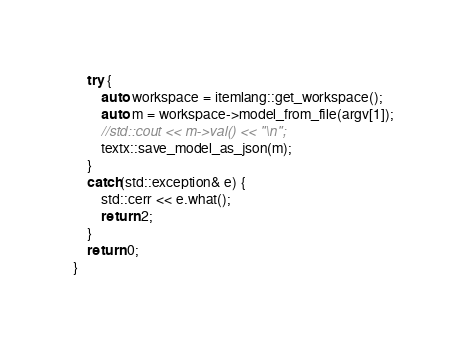Convert code to text. <code><loc_0><loc_0><loc_500><loc_500><_C++_>    try {
        auto workspace = itemlang::get_workspace();
        auto m = workspace->model_from_file(argv[1]);
        //std::cout << m->val() << "\n";
        textx::save_model_as_json(m);
    }
    catch(std::exception& e) {
        std::cerr << e.what();
        return 2;
    }
    return 0;
}</code> 